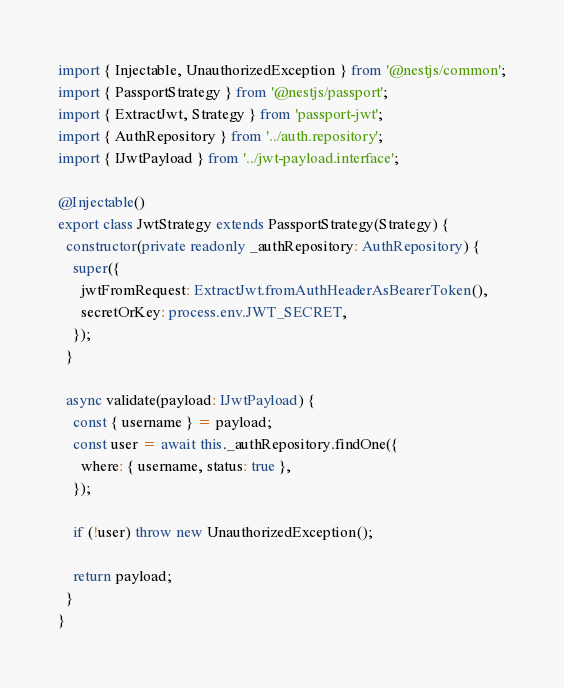Convert code to text. <code><loc_0><loc_0><loc_500><loc_500><_TypeScript_>import { Injectable, UnauthorizedException } from '@nestjs/common';
import { PassportStrategy } from '@nestjs/passport';
import { ExtractJwt, Strategy } from 'passport-jwt';
import { AuthRepository } from '../auth.repository';
import { IJwtPayload } from '../jwt-payload.interface';

@Injectable()
export class JwtStrategy extends PassportStrategy(Strategy) {
  constructor(private readonly _authRepository: AuthRepository) {
    super({
      jwtFromRequest: ExtractJwt.fromAuthHeaderAsBearerToken(),
      secretOrKey: process.env.JWT_SECRET,
    });
  }

  async validate(payload: IJwtPayload) {
    const { username } = payload;
    const user = await this._authRepository.findOne({
      where: { username, status: true },
    });

    if (!user) throw new UnauthorizedException();

    return payload;
  }
}
</code> 